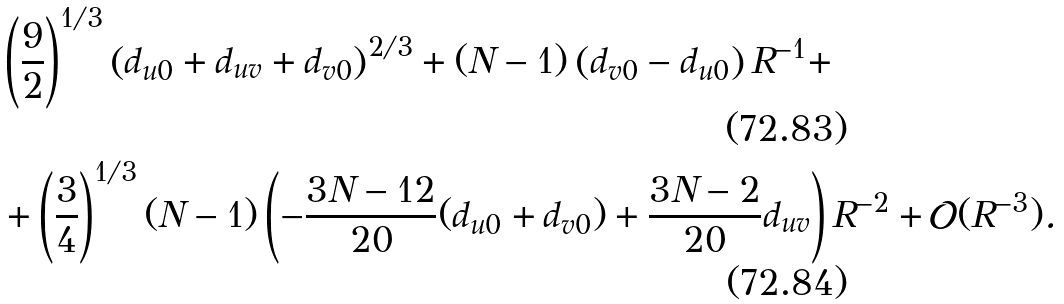Convert formula to latex. <formula><loc_0><loc_0><loc_500><loc_500>& \left ( \frac { 9 } { 2 } \right ) ^ { 1 / 3 } \left ( d _ { u 0 } + d _ { u v } + d _ { v 0 } \right ) ^ { 2 / 3 } + ( N - 1 ) \left ( d _ { v 0 } - d _ { u 0 } \right ) R ^ { - 1 } + \\ & + \left ( \frac { 3 } { 4 } \right ) ^ { 1 / 3 } ( N - 1 ) \left ( - \frac { 3 N - 1 2 } { 2 0 } ( d _ { u 0 } + d _ { v 0 } ) + \frac { 3 N - 2 } { 2 0 } d _ { u v } \right ) R ^ { - 2 } + \mathcal { O } ( R ^ { - 3 } ) .</formula> 